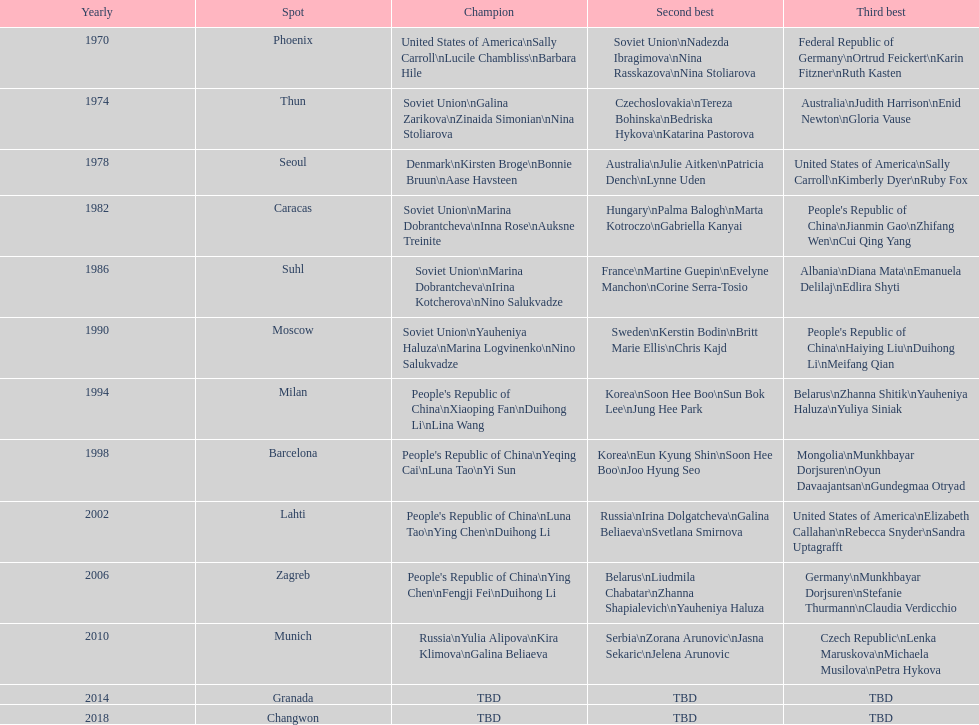Which location is mentioned first in this chart? Phoenix. 